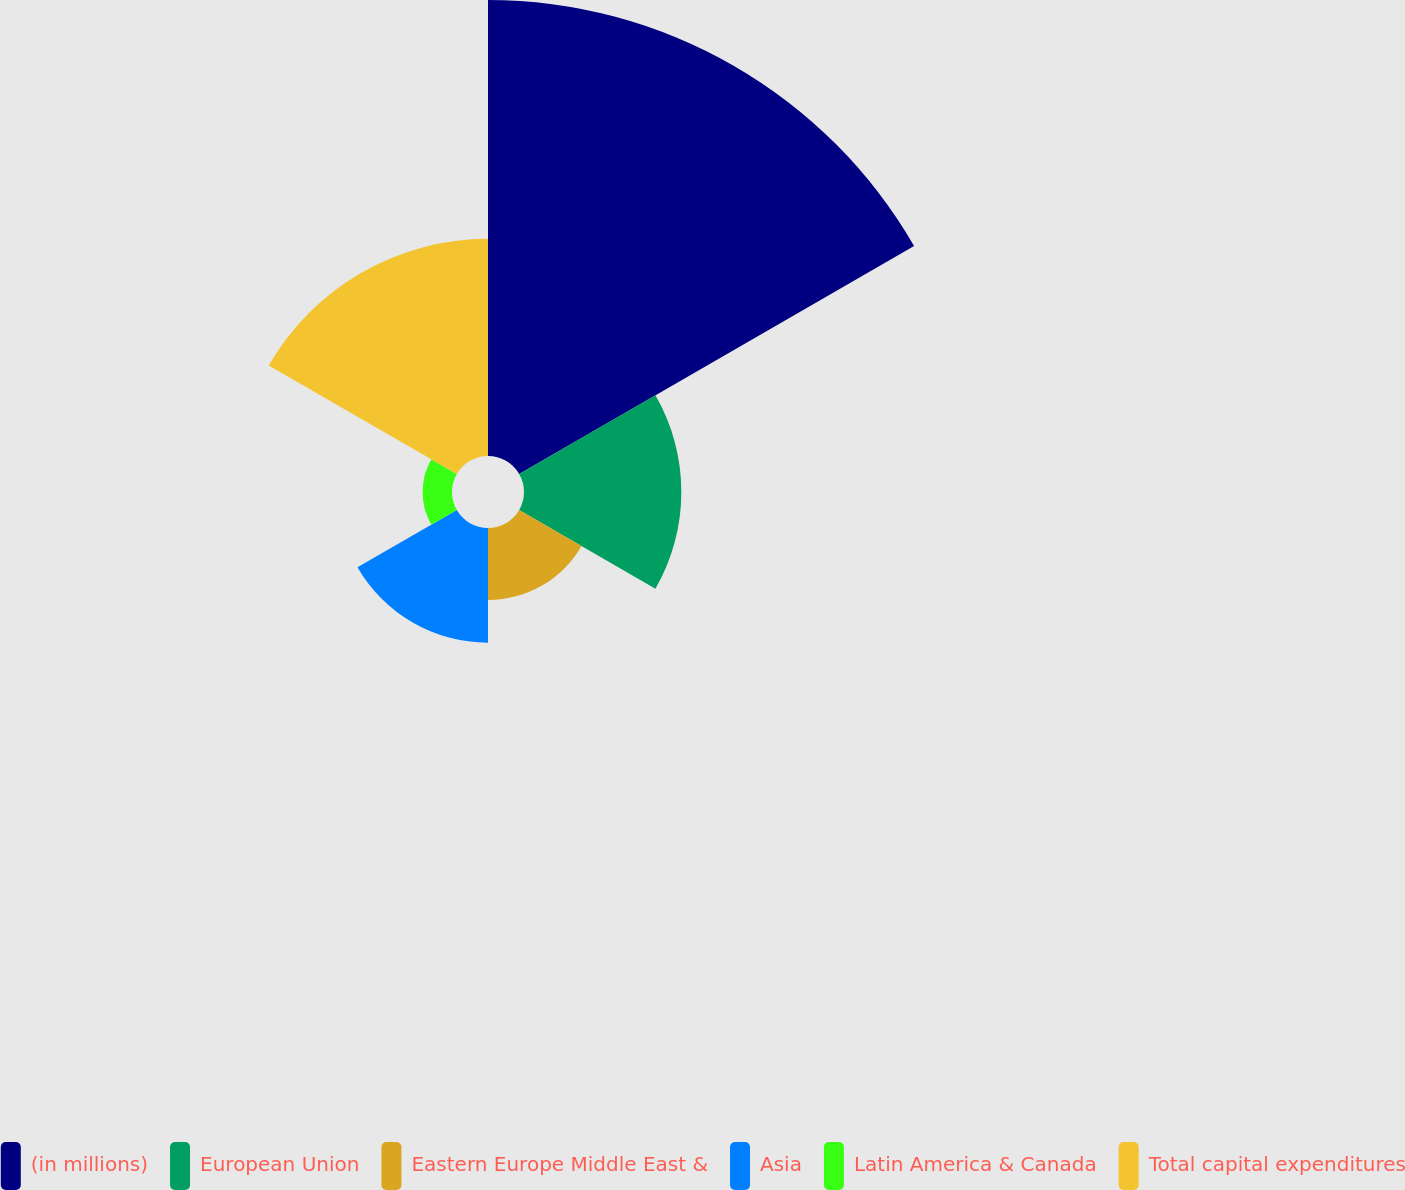<chart> <loc_0><loc_0><loc_500><loc_500><pie_chart><fcel>(in millions)<fcel>European Union<fcel>Eastern Europe Middle East &<fcel>Asia<fcel>Latin America & Canada<fcel>Total capital expenditures<nl><fcel>43.56%<fcel>15.03%<fcel>6.88%<fcel>10.96%<fcel>2.81%<fcel>20.75%<nl></chart> 